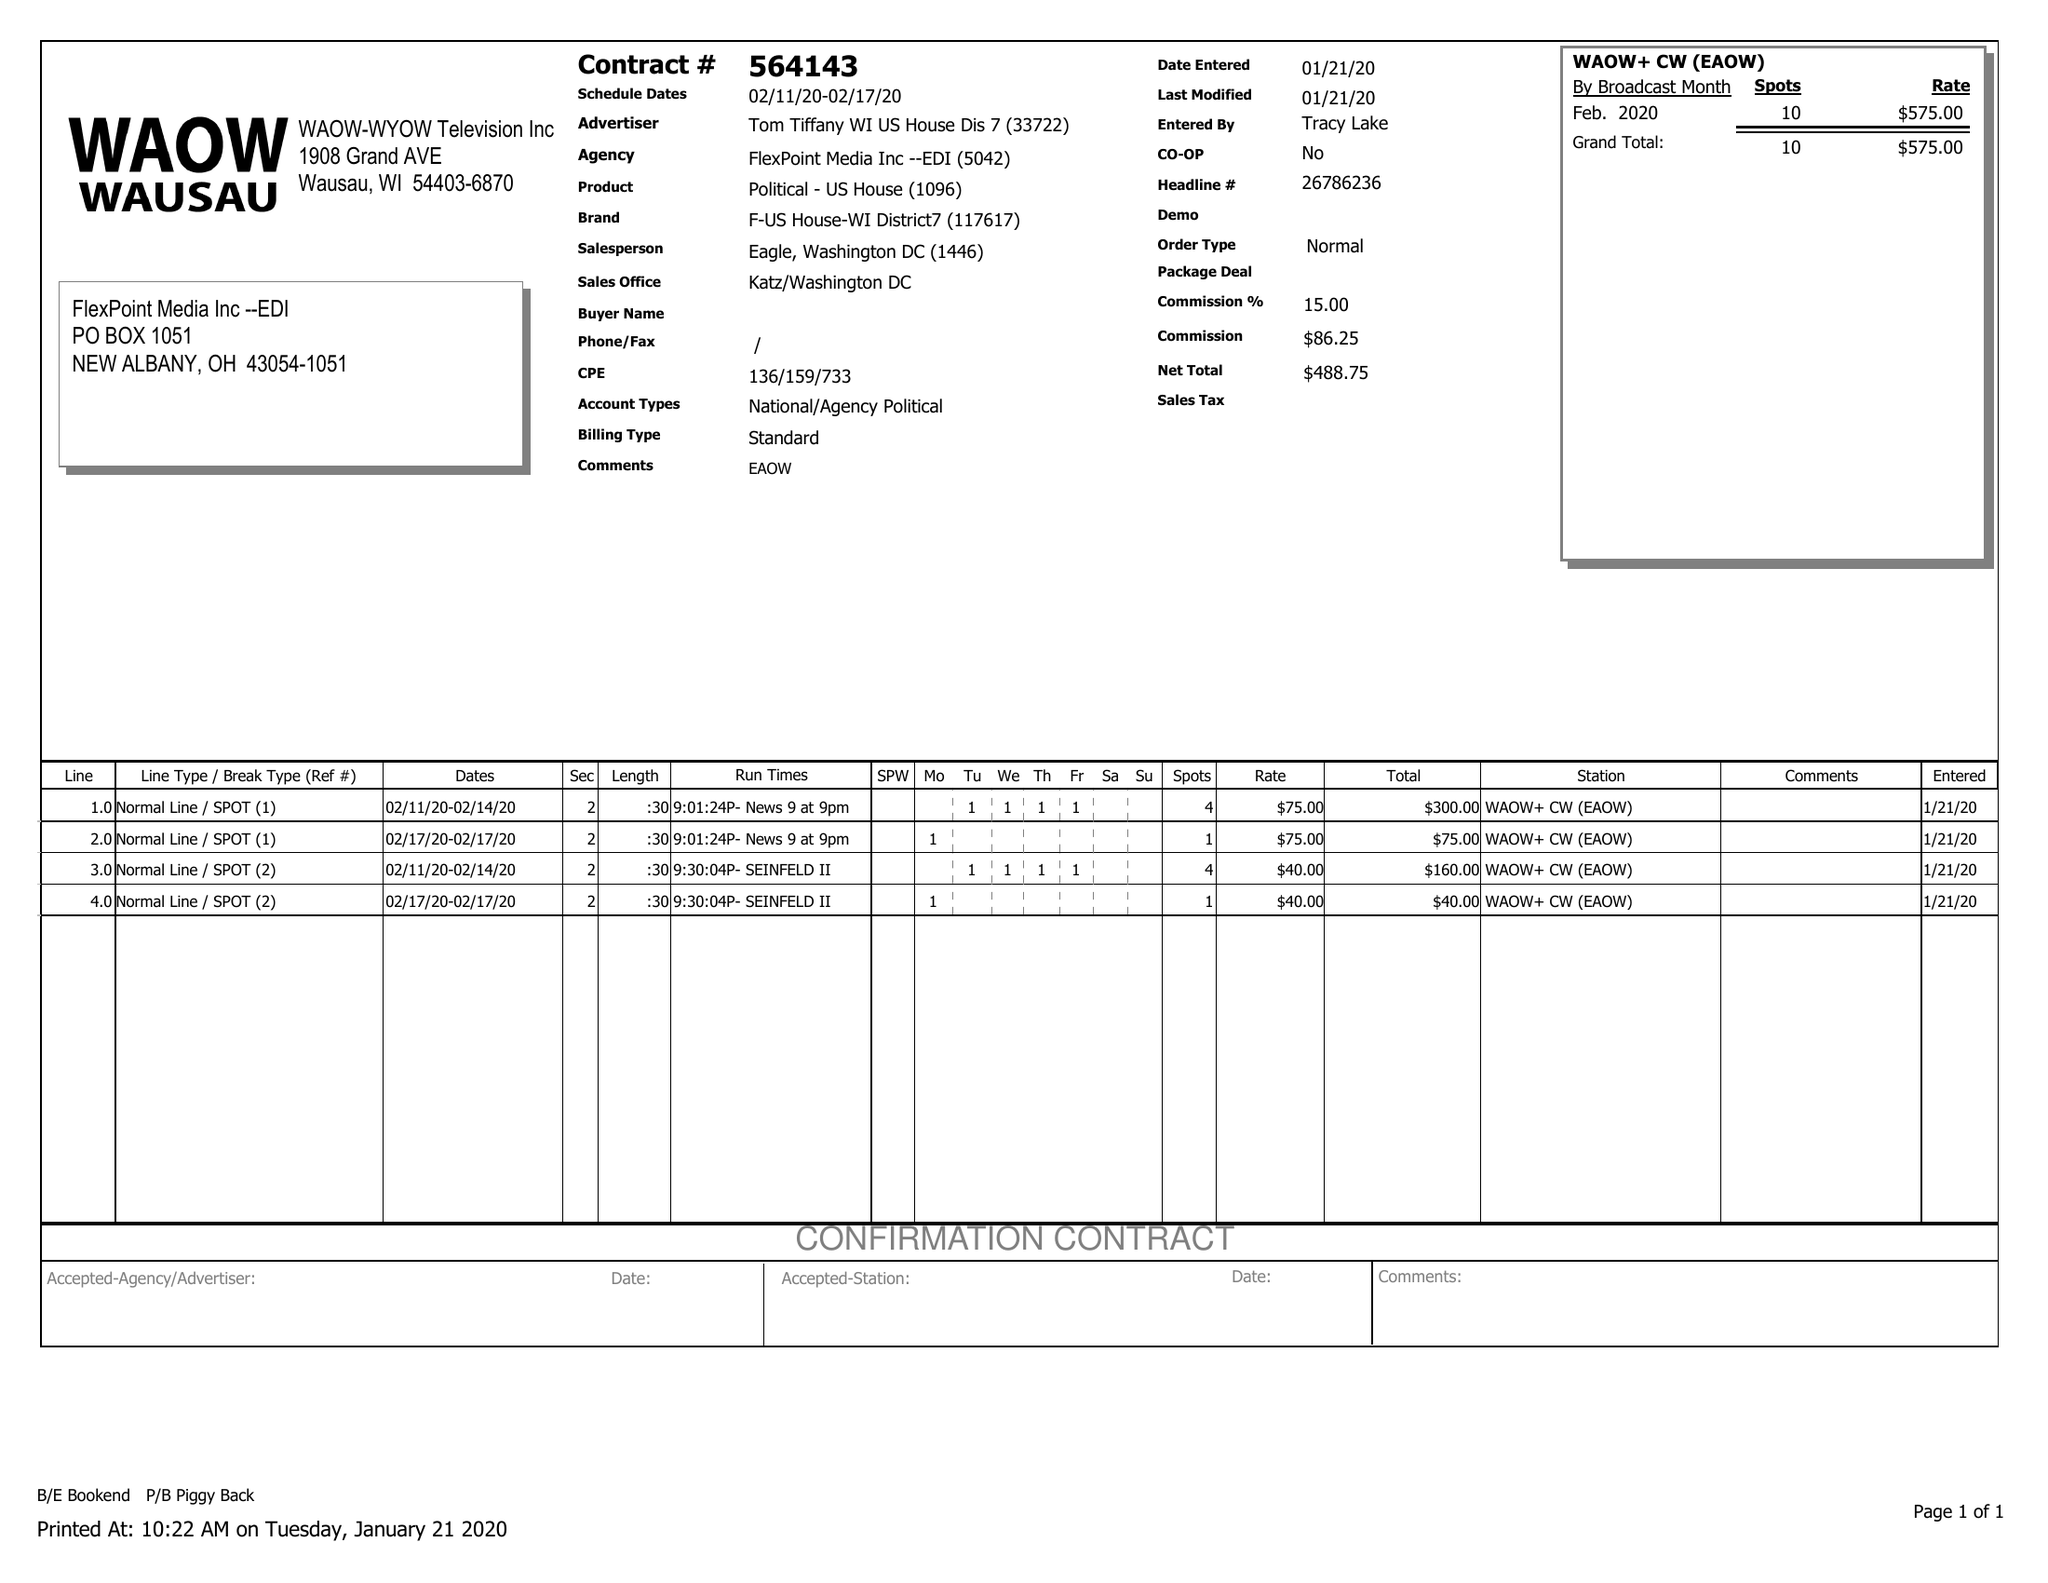What is the value for the advertiser?
Answer the question using a single word or phrase. TOM TIFFANY WI US HOUSE DIS 7 